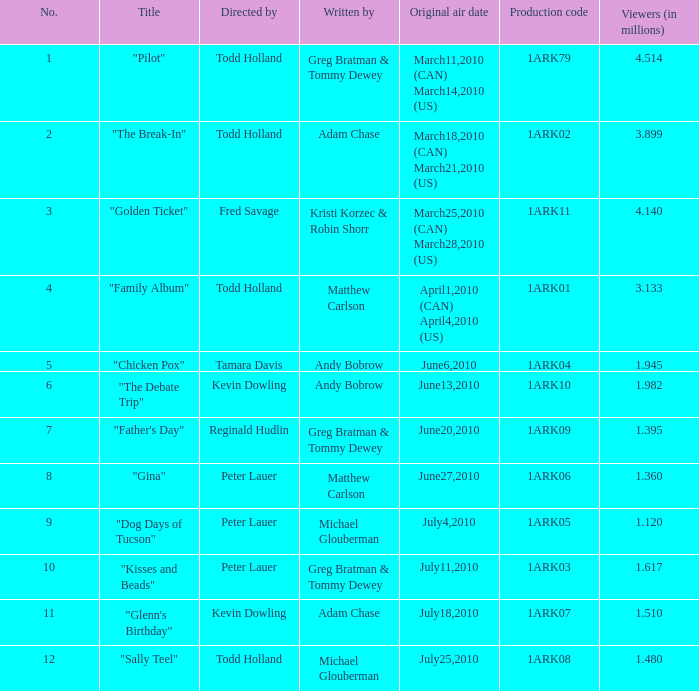How many directors were there for the production code 1ark08? 1.0. 